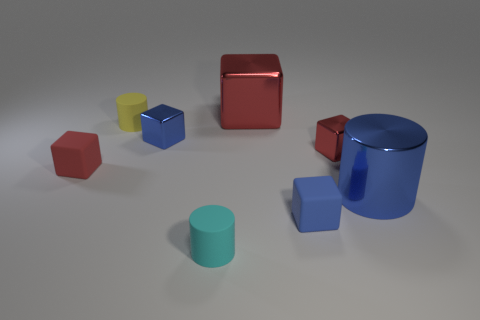How many red blocks must be subtracted to get 1 red blocks? 2 Subtract all gray spheres. How many red blocks are left? 3 Subtract 2 blocks. How many blocks are left? 3 Subtract all big red blocks. How many blocks are left? 4 Subtract all brown cubes. Subtract all gray cylinders. How many cubes are left? 5 Add 1 red metallic things. How many objects exist? 9 Subtract all blocks. How many objects are left? 3 Subtract all green shiny blocks. Subtract all small cyan cylinders. How many objects are left? 7 Add 6 small yellow matte cylinders. How many small yellow matte cylinders are left? 7 Add 1 yellow matte things. How many yellow matte things exist? 2 